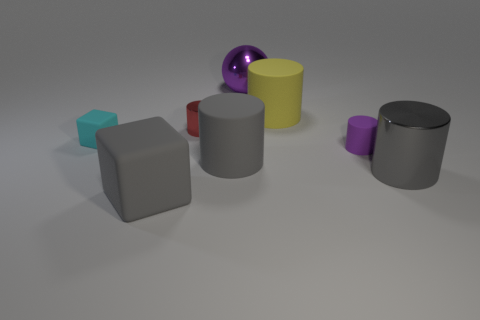Are there any red things?
Your response must be concise. Yes. There is a gray cylinder that is to the right of the big rubber cylinder in front of the small metallic object; what size is it?
Offer a terse response. Large. Are there more big purple things that are to the left of the gray matte block than cylinders that are on the right side of the large metallic cylinder?
Offer a terse response. No. How many cubes are red metal objects or big purple metal objects?
Give a very brief answer. 0. Are there any other things that are the same size as the gray rubber cylinder?
Your answer should be compact. Yes. Do the big metallic object behind the yellow cylinder and the yellow thing have the same shape?
Your answer should be very brief. No. What color is the small metallic thing?
Your answer should be compact. Red. What color is the other small matte thing that is the same shape as the red object?
Offer a very short reply. Purple. What number of tiny green things are the same shape as the cyan matte object?
Provide a short and direct response. 0. How many things are either large gray matte cylinders or small rubber objects that are right of the small cyan matte block?
Offer a very short reply. 2. 